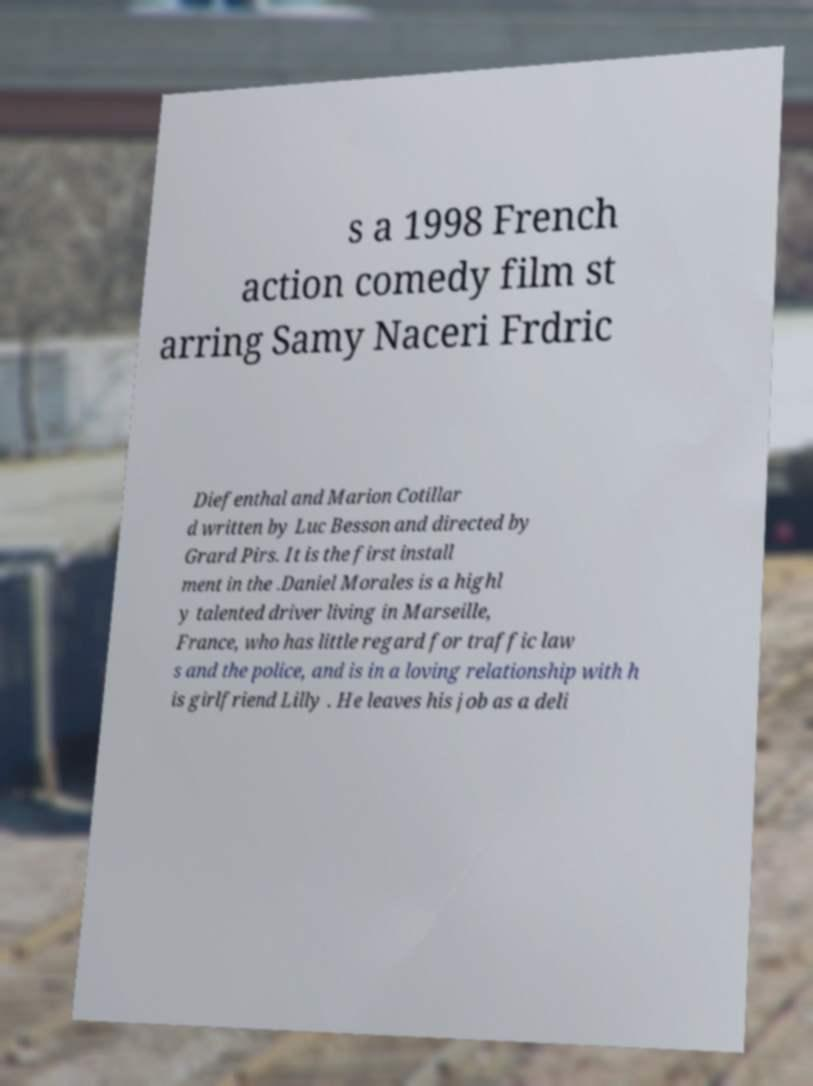Please read and relay the text visible in this image. What does it say? s a 1998 French action comedy film st arring Samy Naceri Frdric Diefenthal and Marion Cotillar d written by Luc Besson and directed by Grard Pirs. It is the first install ment in the .Daniel Morales is a highl y talented driver living in Marseille, France, who has little regard for traffic law s and the police, and is in a loving relationship with h is girlfriend Lilly . He leaves his job as a deli 